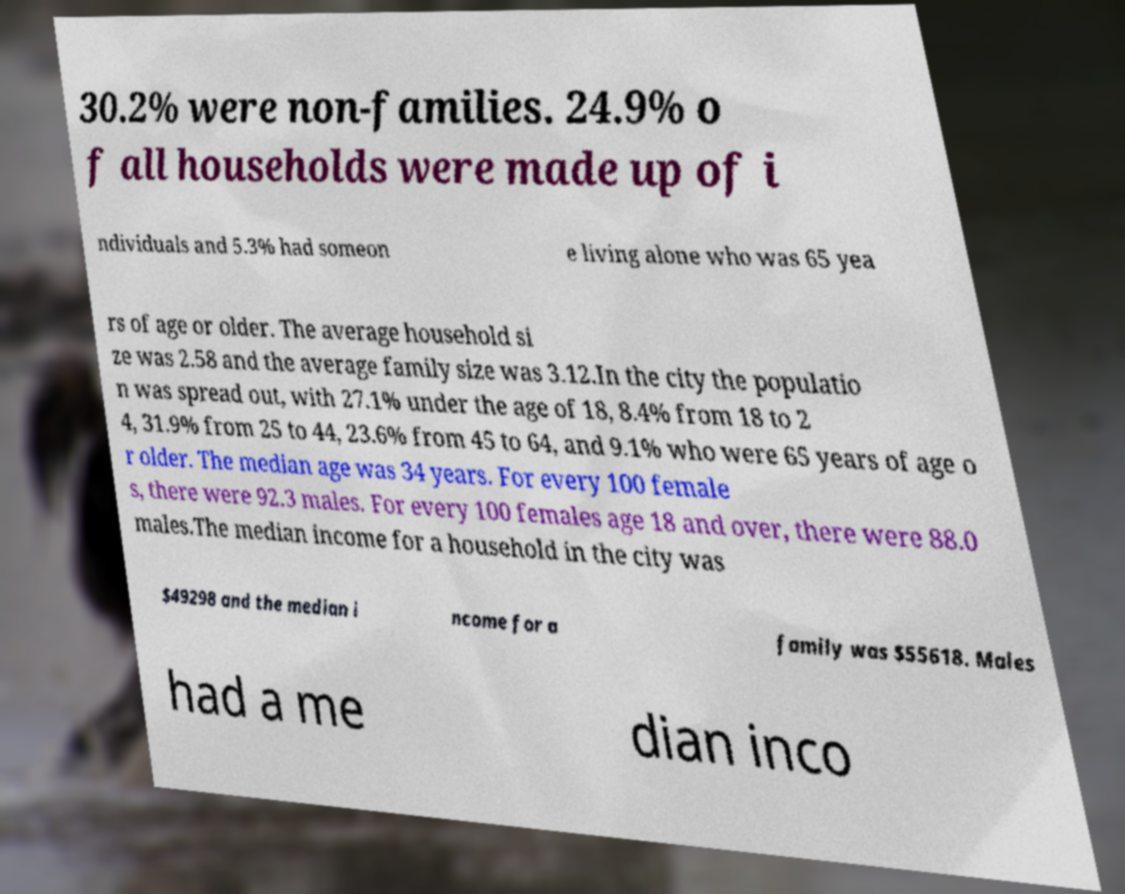Please identify and transcribe the text found in this image. 30.2% were non-families. 24.9% o f all households were made up of i ndividuals and 5.3% had someon e living alone who was 65 yea rs of age or older. The average household si ze was 2.58 and the average family size was 3.12.In the city the populatio n was spread out, with 27.1% under the age of 18, 8.4% from 18 to 2 4, 31.9% from 25 to 44, 23.6% from 45 to 64, and 9.1% who were 65 years of age o r older. The median age was 34 years. For every 100 female s, there were 92.3 males. For every 100 females age 18 and over, there were 88.0 males.The median income for a household in the city was $49298 and the median i ncome for a family was $55618. Males had a me dian inco 